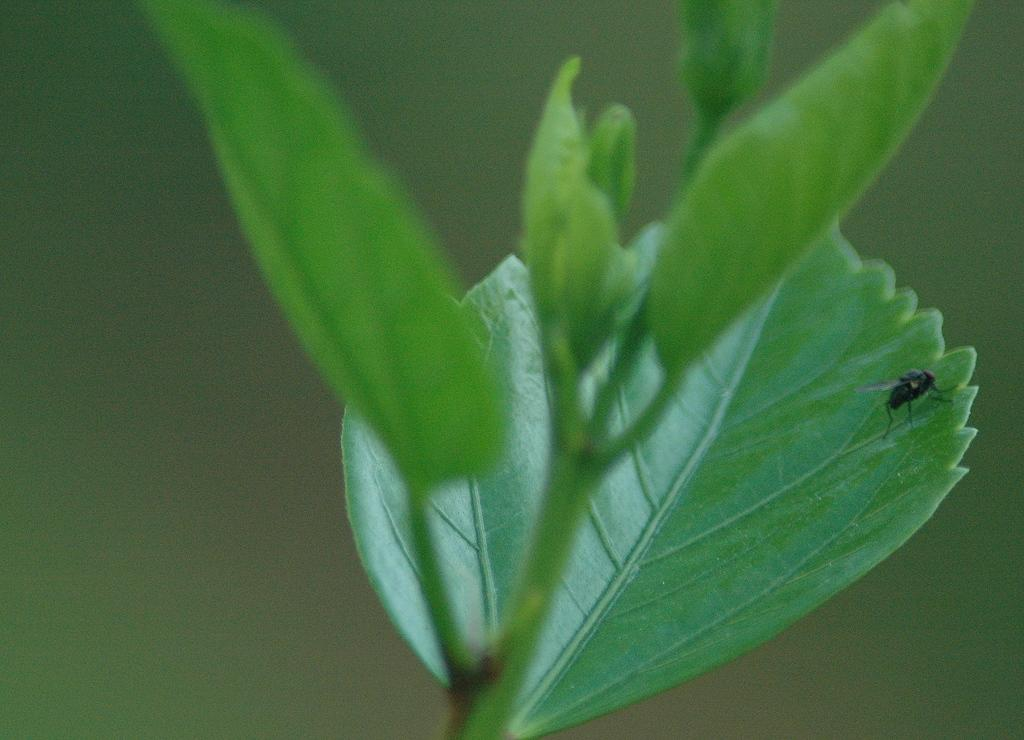What is present in the picture? There is a plant in the picture. Can you describe the plant further? There is a fly on one of the plant's leaves. Where is the hose connected to the plant in the image? There is no hose present in the image. What type of hat is the fly wearing in the image? Flies do not wear hats, and there is no hat present in the image. 